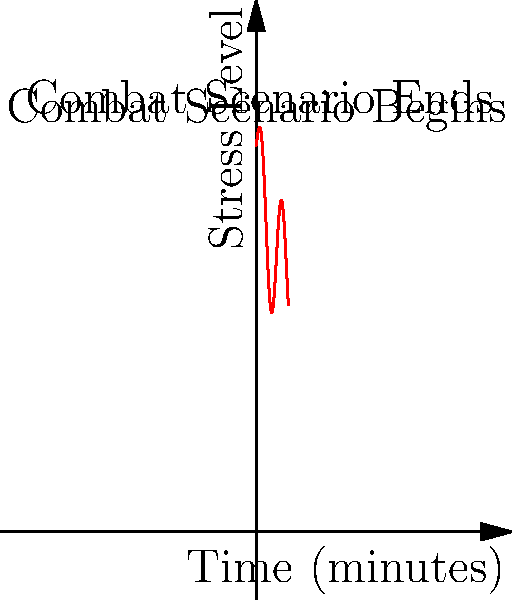During a simulated combat scenario, a military officer's stress level (measured on a scale from 0 to 100) is modeled by the function $f(t) = 80 + 20\sin(t) + 40e^{-t/3}$, where $t$ is the time in minutes. Calculate the average stress level experienced by the officer over the 10-minute duration of the scenario. To find the average stress level, we need to:

1) Calculate the total accumulated stress over the 10-minute period using integration.
2) Divide the result by the total time (10 minutes).

Step 1: Set up the integral
$$\int_0^{10} (80 + 20\sin(t) + 40e^{-t/3}) dt$$

Step 2: Integrate each term separately
a) $\int 80 dt = 80t$
b) $\int 20\sin(t) dt = -20\cos(t)$
c) $\int 40e^{-t/3} dt = -120e^{-t/3}$

Step 3: Apply the fundamental theorem of calculus
$$\left[80t - 20\cos(t) - 120e^{-t/3}\right]_0^{10}$$

Step 4: Evaluate the expression
$$(800 - 20\cos(10) - 120e^{-10/3}) - (0 - 20\cos(0) - 120)$$
$$= 800 - 20\cos(10) - 120e^{-10/3} + 20 + 120$$
$$= 940 - 20\cos(10) - 120e^{-10/3}$$

Step 5: Calculate the average by dividing by 10
Average stress level = $(940 - 20\cos(10) - 120e^{-10/3}) / 10$
$$= 94 - 2\cos(10) - 12e^{-10/3}$$

Using a calculator for the final computation:
Average stress level ≈ 88.37
Answer: 88.37 